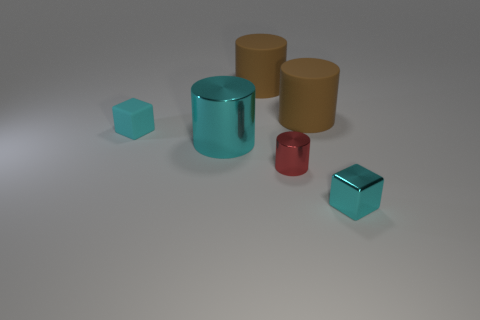Which objects in this image could serve as containers, and what might they hold? The cylinder in the center looks like it could act as a container. Given its size, it might be suitable for holding pens or other small desk items. Could any of the other objects function as containers as well? Strictly based on the image, the other objects do not have the cavity or shape to function as containers. They are solid and not designed to hold items. 